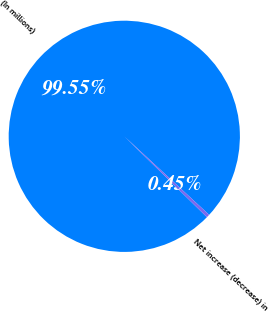Convert chart. <chart><loc_0><loc_0><loc_500><loc_500><pie_chart><fcel>(In millions)<fcel>Net increase (decrease) in<nl><fcel>99.55%<fcel>0.45%<nl></chart> 